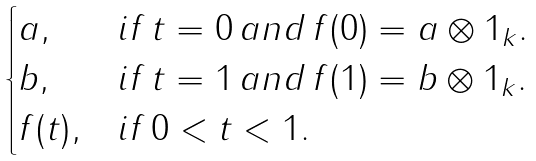Convert formula to latex. <formula><loc_0><loc_0><loc_500><loc_500>\begin{cases} a , & i f \, t = 0 \, a n d \, f ( 0 ) = a \otimes 1 _ { k } . \\ b , & i f \, t = 1 \, a n d \, f ( 1 ) = b \otimes 1 _ { k } . \\ f ( t ) , & i f \, 0 < t < 1 . \end{cases}</formula> 